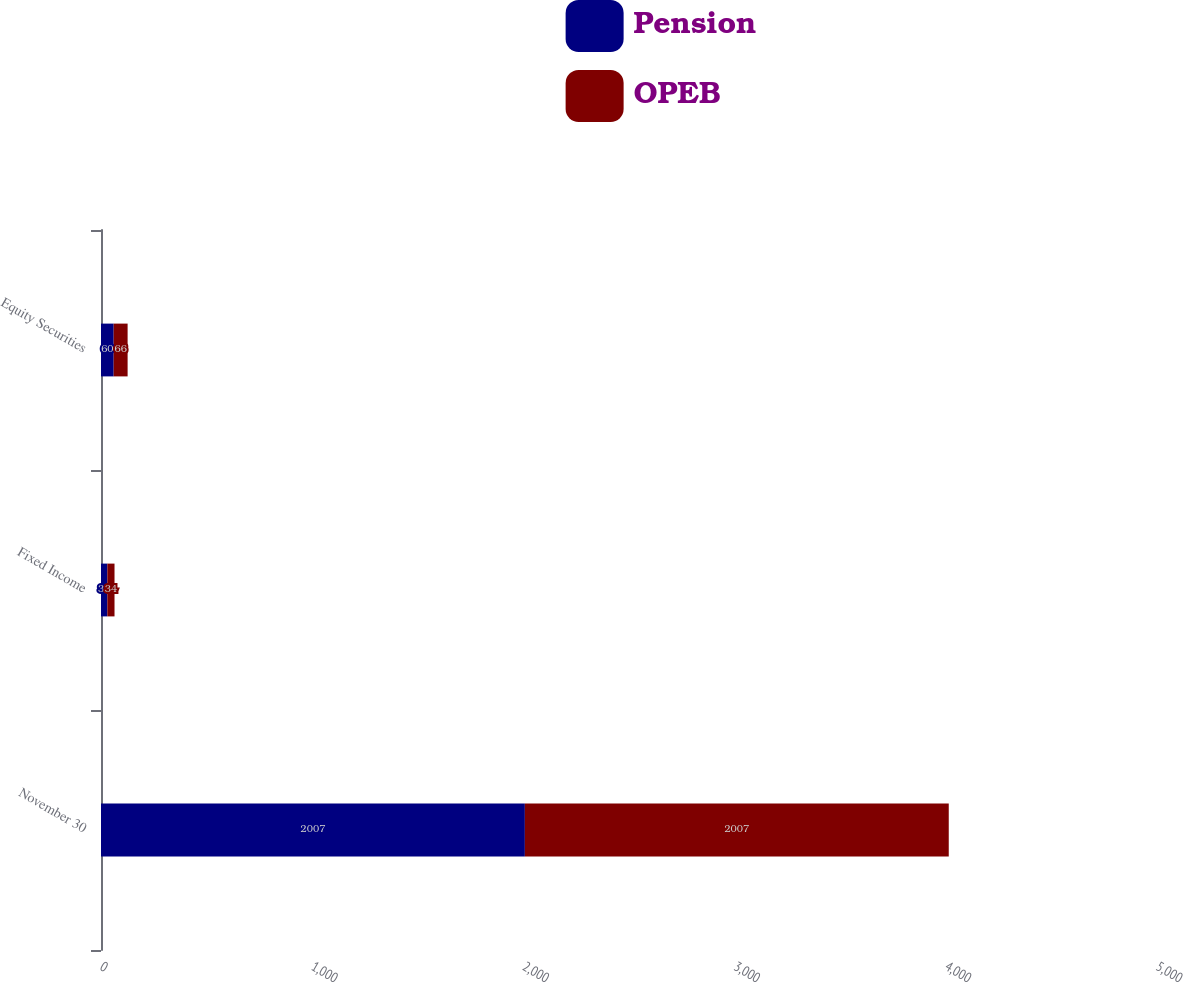Convert chart to OTSL. <chart><loc_0><loc_0><loc_500><loc_500><stacked_bar_chart><ecel><fcel>November 30<fcel>Fixed Income<fcel>Equity Securities<nl><fcel>Pension<fcel>2007<fcel>30<fcel>60<nl><fcel>OPEB<fcel>2007<fcel>34<fcel>66<nl></chart> 